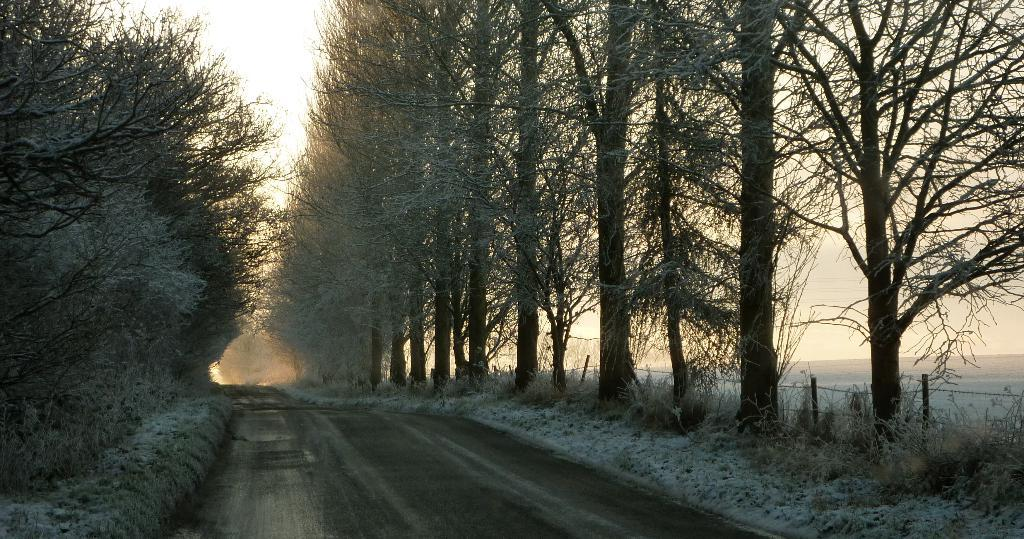What can be seen in the foreground of the picture? There are plants, a road, and trees in the foreground of the picture. What is located in the center of the picture? There are trees in the center of the picture. What is on the right side of the picture? There is a field on the right side of the picture. What type of cheese is hanging from the trees in the picture? There is no cheese present in the picture; it features plants, a road, trees, and a field. How many cherries can be seen in the center of the picture? There are no cherries present in the picture; it features trees in the center. 